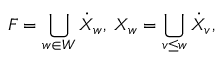<formula> <loc_0><loc_0><loc_500><loc_500>F = \bigcup _ { w \in W } \dot { X } _ { w } , \, X _ { w } = \bigcup _ { v \leq w } \dot { X } _ { v } ,</formula> 